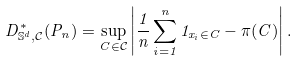<formula> <loc_0><loc_0><loc_500><loc_500>D ^ { \ast } _ { \mathbb { S } ^ { d } , \mathcal { C } } ( P _ { n } ) = \sup _ { C \in \mathcal { C } } \left | \frac { 1 } { n } \sum _ { i = 1 } ^ { n } 1 _ { x _ { i } \in C } - \pi ( C ) \right | .</formula> 